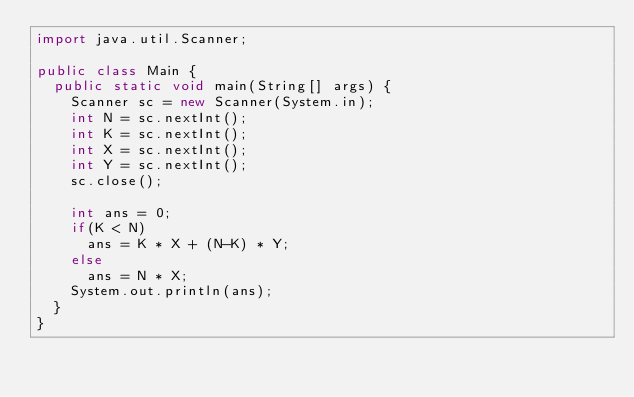<code> <loc_0><loc_0><loc_500><loc_500><_Java_>import java.util.Scanner;

public class Main {
	public static void main(String[] args) {
		Scanner sc = new Scanner(System.in);
		int N = sc.nextInt();
		int K = sc.nextInt();
		int X = sc.nextInt();
		int Y = sc.nextInt();
		sc.close();
		
		int ans = 0;
		if(K < N)
			ans = K * X + (N-K) * Y;
		else
			ans = N * X;
		System.out.println(ans);
	}
}
</code> 